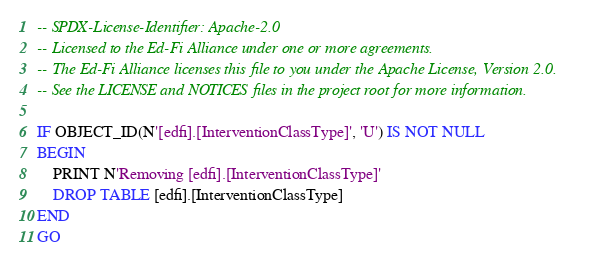Convert code to text. <code><loc_0><loc_0><loc_500><loc_500><_SQL_>-- SPDX-License-Identifier: Apache-2.0
-- Licensed to the Ed-Fi Alliance under one or more agreements.
-- The Ed-Fi Alliance licenses this file to you under the Apache License, Version 2.0.
-- See the LICENSE and NOTICES files in the project root for more information.

IF OBJECT_ID(N'[edfi].[InterventionClassType]', 'U') IS NOT NULL
BEGIN
	PRINT N'Removing [edfi].[InterventionClassType]'
	DROP TABLE [edfi].[InterventionClassType]
END
GO

</code> 